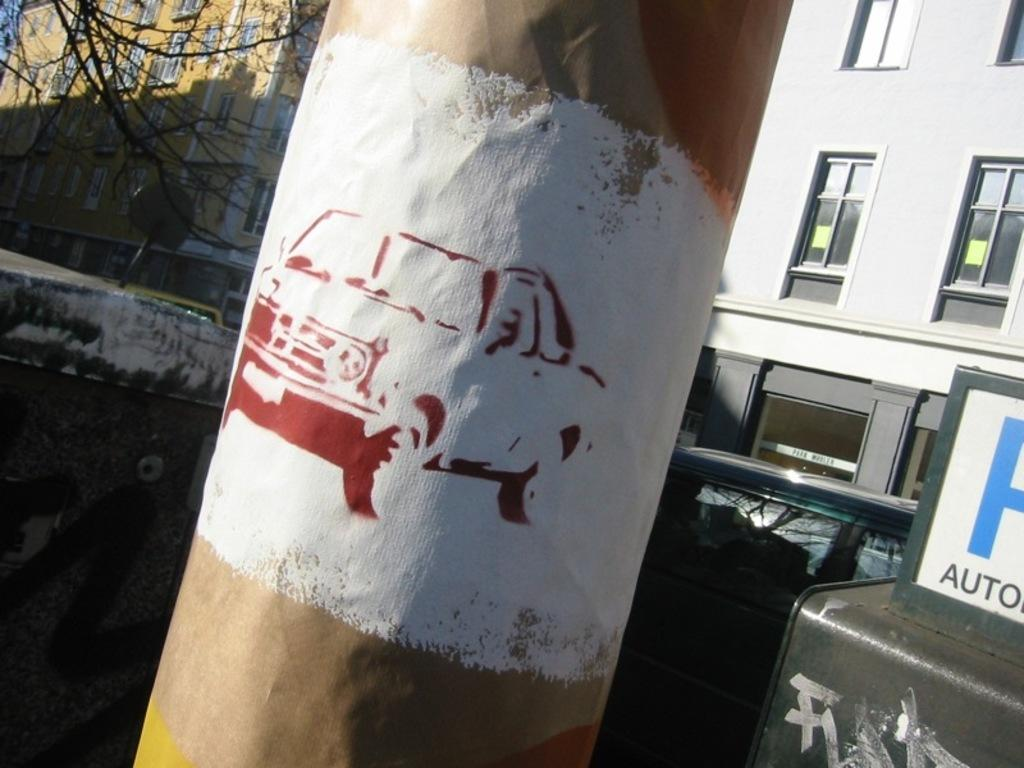What is depicted on the pillar in the image? There is a car drawing on a pillar in the image. What can be seen in the background of the image? There are buildings, windows, a bare tree, and vehicles in the background. Can you describe the object in the bottom right corner of the image? Unfortunately, the provided facts do not give any information about the object in the bottom right corner of the image. What type of bells can be heard ringing in the image? There are no bells present in the image, and therefore no sound can be heard. 